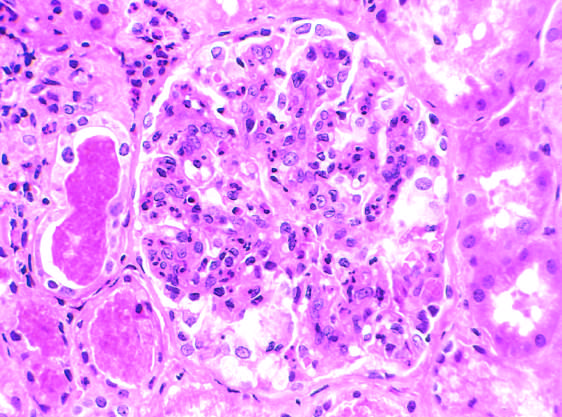what is caused by intracapillary leukocytes and proliferation of intrinsic glomerular cells?
Answer the question using a single word or phrase. Glomerular hypercellularity 